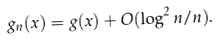Convert formula to latex. <formula><loc_0><loc_0><loc_500><loc_500>g _ { n } ( x ) = g ( x ) + O ( \log ^ { 2 } n / n ) .</formula> 